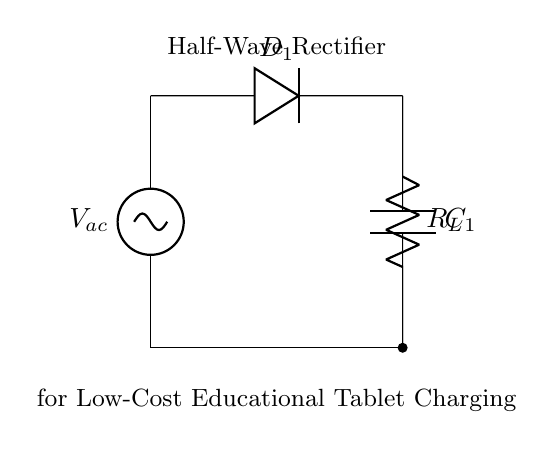What type of rectifier is shown? The circuit is a half-wave rectifier because it only allows one half of the AC waveform to pass through while blocking the other half, which is typical of half-wave rectifiers.
Answer: Half-wave What component is used to convert AC to DC? The diode, labeled D1, is the component that allows current to pass in one direction, effectively blocking the negative half of the AC wave and converting it to DC.
Answer: Diode What is the purpose of the capacitor in this circuit? The capacitor, labeled C1, stores charge and helps to smooth the DC output voltage from the diode by reducing voltage fluctuations after rectification.
Answer: Smoothing What is the load component for this circuit? The load resistor, labeled R_L, represents the device that will consume the electricity supplied by the rectifier, in this case, the educational tablets.
Answer: Load resistor What happens to the voltage during the negative cycle of the AC waveform? During the negative cycle, the diode blocks the current flow, so no voltage is applied to the load resistor and capacitor, leading to a zero voltage condition.
Answer: Zero voltage What is the name of the AC voltage source in the circuit? The AC source is represented as V_ac, which provides the alternating current necessary for the rectification process.
Answer: V_ac 